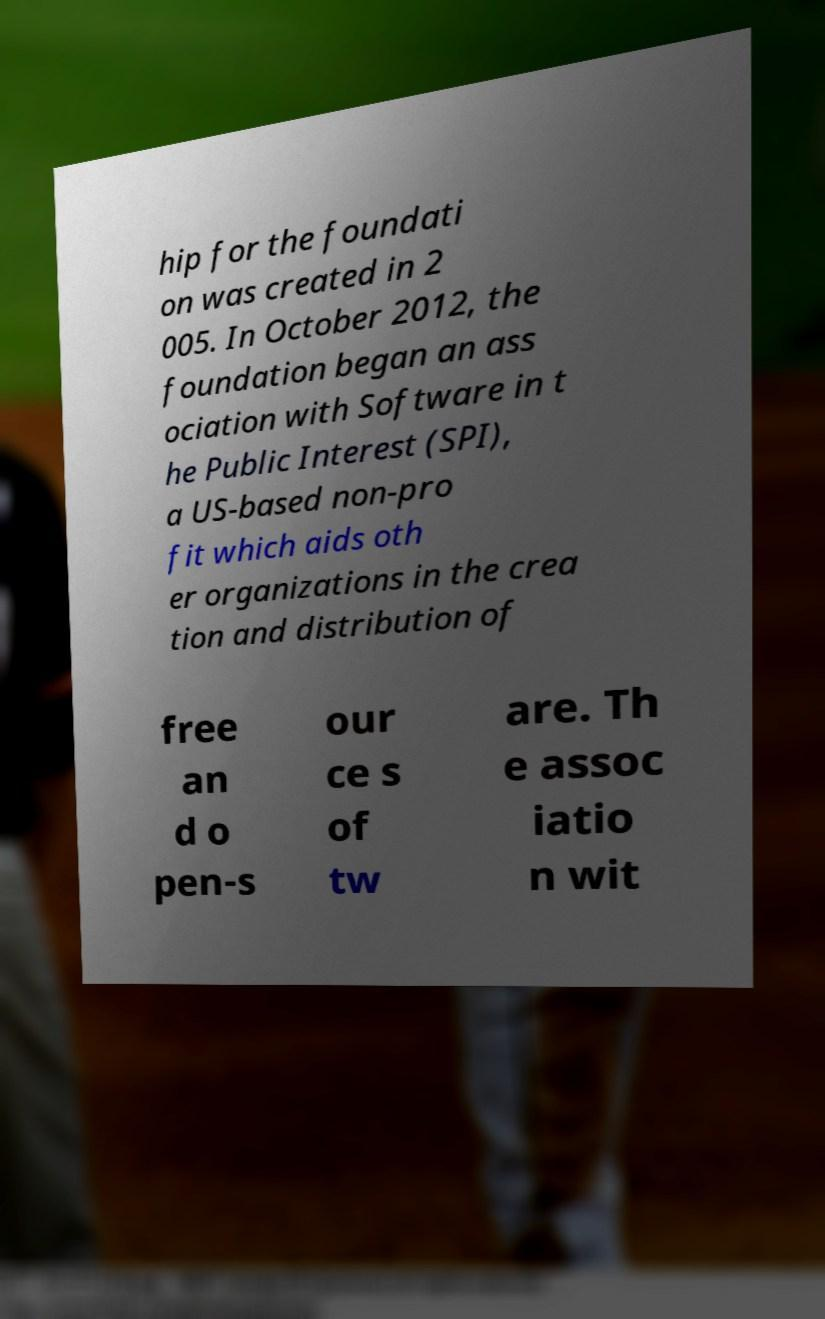Could you assist in decoding the text presented in this image and type it out clearly? hip for the foundati on was created in 2 005. In October 2012, the foundation began an ass ociation with Software in t he Public Interest (SPI), a US-based non-pro fit which aids oth er organizations in the crea tion and distribution of free an d o pen-s our ce s of tw are. Th e assoc iatio n wit 